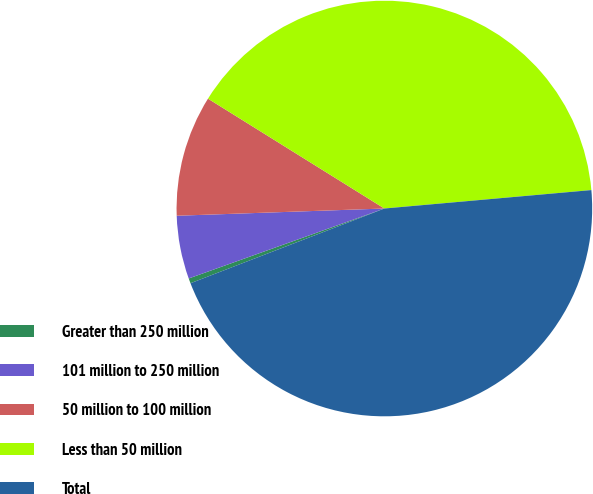Convert chart. <chart><loc_0><loc_0><loc_500><loc_500><pie_chart><fcel>Greater than 250 million<fcel>101 million to 250 million<fcel>50 million to 100 million<fcel>Less than 50 million<fcel>Total<nl><fcel>0.39%<fcel>4.91%<fcel>9.42%<fcel>39.72%<fcel>45.56%<nl></chart> 